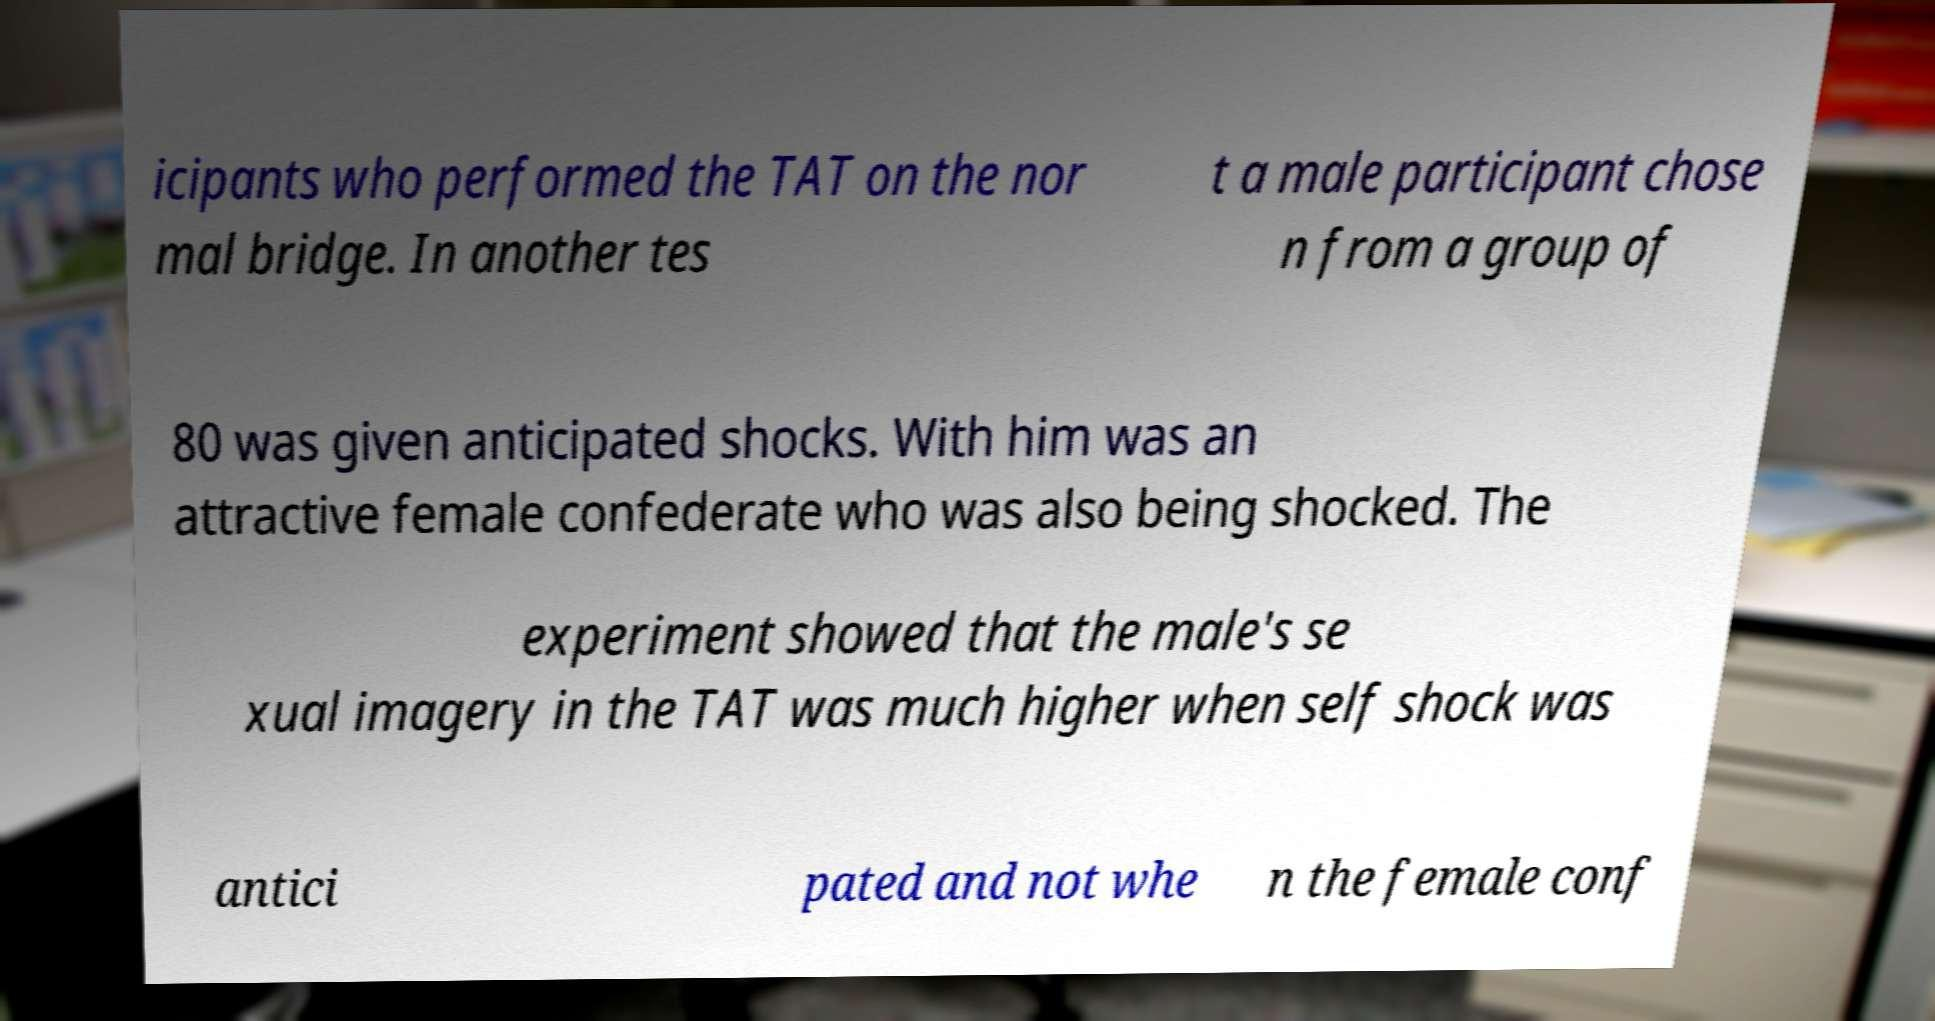What messages or text are displayed in this image? I need them in a readable, typed format. icipants who performed the TAT on the nor mal bridge. In another tes t a male participant chose n from a group of 80 was given anticipated shocks. With him was an attractive female confederate who was also being shocked. The experiment showed that the male's se xual imagery in the TAT was much higher when self shock was antici pated and not whe n the female conf 